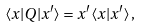<formula> <loc_0><loc_0><loc_500><loc_500>\langle x | Q | x ^ { \prime } \rangle = x ^ { \prime } \langle x | x ^ { \prime } \rangle \, ,</formula> 